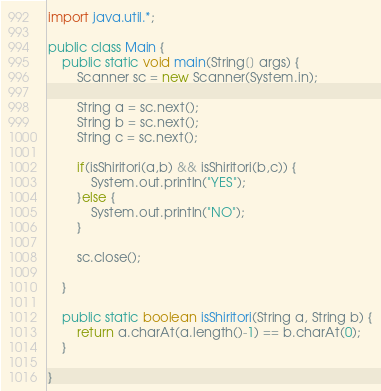<code> <loc_0><loc_0><loc_500><loc_500><_Java_>import java.util.*;

public class Main {
	public static void main(String[] args) {
		Scanner sc = new Scanner(System.in);
		
		String a = sc.next();
		String b = sc.next();
		String c = sc.next();
		
		if(isShiritori(a,b) && isShiritori(b,c)) {
			System.out.println("YES");
		}else {
			System.out.println("NO");
		}
		
		sc.close();

	}
	
	public static boolean isShiritori(String a, String b) {
		return a.charAt(a.length()-1) == b.charAt(0);
	}

}

</code> 